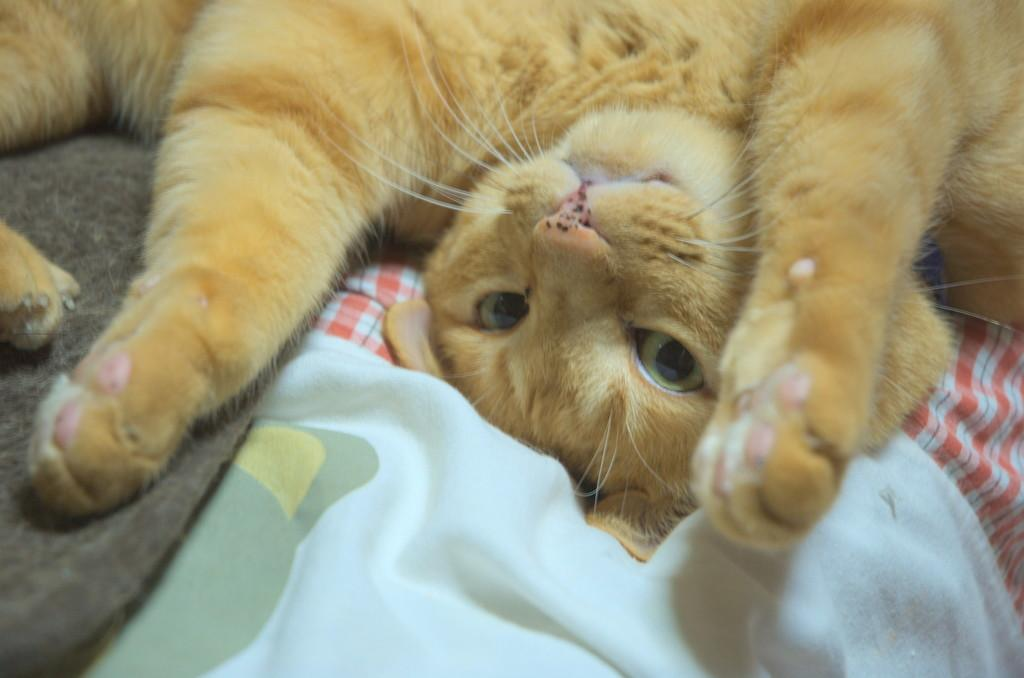What type of animal is on the couch in the image? There is a cat on the couch in the image. What else can be seen in the image besides the cat? Clothes are visible in the image. What channel is the cat watching on the television in the image? There is no television present in the image, so it is not possible to determine what channel the cat might be watching. 